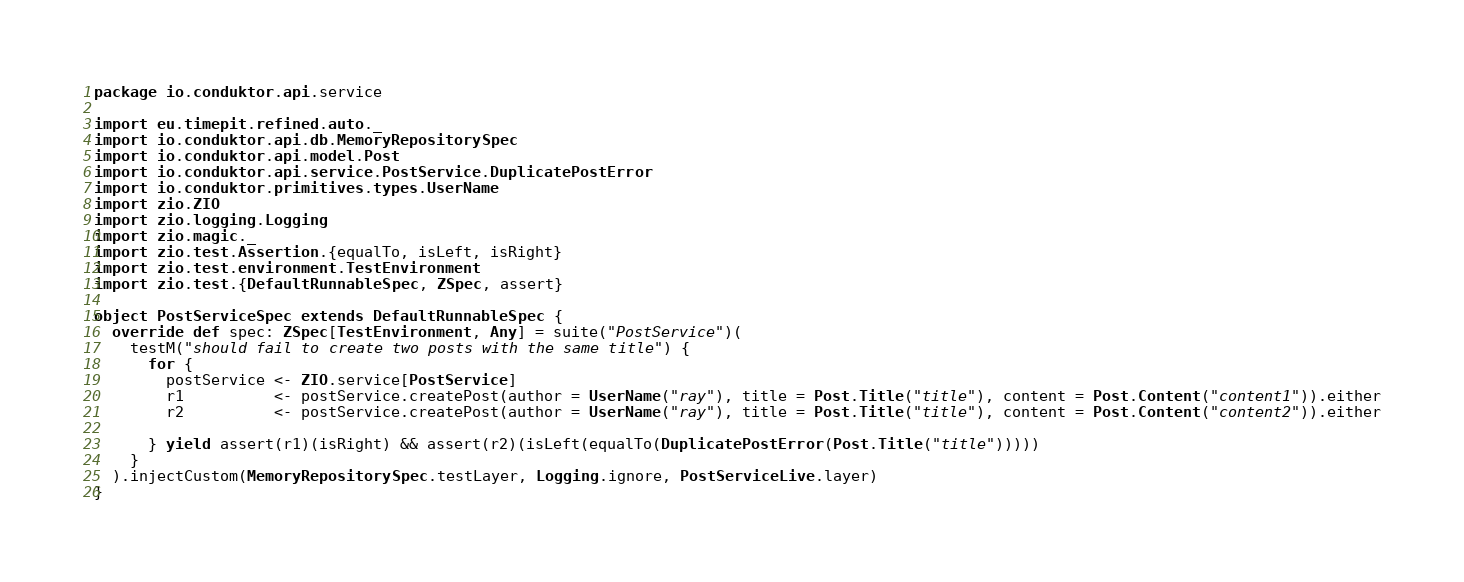Convert code to text. <code><loc_0><loc_0><loc_500><loc_500><_Scala_>package io.conduktor.api.service

import eu.timepit.refined.auto._
import io.conduktor.api.db.MemoryRepositorySpec
import io.conduktor.api.model.Post
import io.conduktor.api.service.PostService.DuplicatePostError
import io.conduktor.primitives.types.UserName
import zio.ZIO
import zio.logging.Logging
import zio.magic._
import zio.test.Assertion.{equalTo, isLeft, isRight}
import zio.test.environment.TestEnvironment
import zio.test.{DefaultRunnableSpec, ZSpec, assert}

object PostServiceSpec extends DefaultRunnableSpec {
  override def spec: ZSpec[TestEnvironment, Any] = suite("PostService")(
    testM("should fail to create two posts with the same title") {
      for {
        postService <- ZIO.service[PostService]
        r1          <- postService.createPost(author = UserName("ray"), title = Post.Title("title"), content = Post.Content("content1")).either
        r2          <- postService.createPost(author = UserName("ray"), title = Post.Title("title"), content = Post.Content("content2")).either

      } yield assert(r1)(isRight) && assert(r2)(isLeft(equalTo(DuplicatePostError(Post.Title("title")))))
    }
  ).injectCustom(MemoryRepositorySpec.testLayer, Logging.ignore, PostServiceLive.layer)
}
</code> 